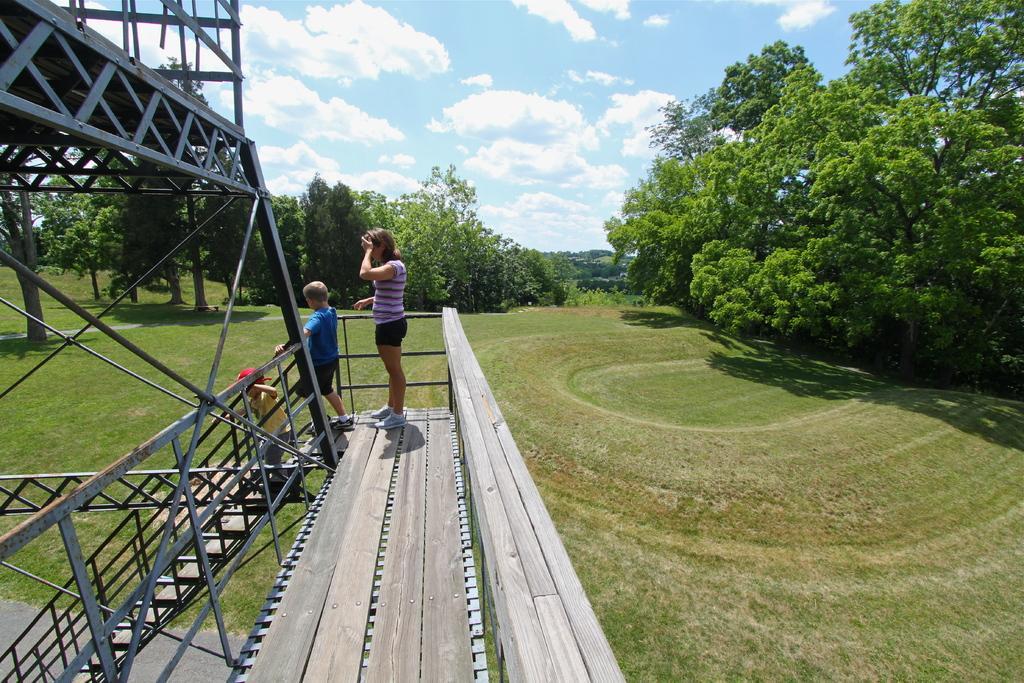Can you describe this image briefly? In this image there is a lady and two children's are standing on the wooden floor in front of the stairs, one of them is standing on the stairs, beside them there is a metal structure. In the background there are trees and the sky. 